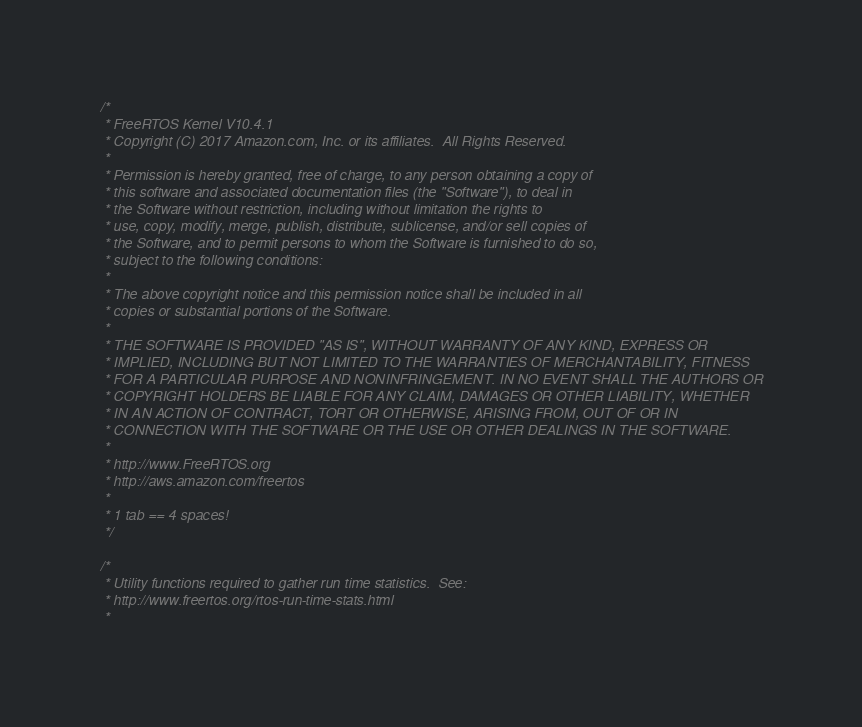<code> <loc_0><loc_0><loc_500><loc_500><_C_>/*
 * FreeRTOS Kernel V10.4.1
 * Copyright (C) 2017 Amazon.com, Inc. or its affiliates.  All Rights Reserved.
 *
 * Permission is hereby granted, free of charge, to any person obtaining a copy of
 * this software and associated documentation files (the "Software"), to deal in
 * the Software without restriction, including without limitation the rights to
 * use, copy, modify, merge, publish, distribute, sublicense, and/or sell copies of
 * the Software, and to permit persons to whom the Software is furnished to do so,
 * subject to the following conditions:
 *
 * The above copyright notice and this permission notice shall be included in all
 * copies or substantial portions of the Software.
 *
 * THE SOFTWARE IS PROVIDED "AS IS", WITHOUT WARRANTY OF ANY KIND, EXPRESS OR
 * IMPLIED, INCLUDING BUT NOT LIMITED TO THE WARRANTIES OF MERCHANTABILITY, FITNESS
 * FOR A PARTICULAR PURPOSE AND NONINFRINGEMENT. IN NO EVENT SHALL THE AUTHORS OR
 * COPYRIGHT HOLDERS BE LIABLE FOR ANY CLAIM, DAMAGES OR OTHER LIABILITY, WHETHER
 * IN AN ACTION OF CONTRACT, TORT OR OTHERWISE, ARISING FROM, OUT OF OR IN
 * CONNECTION WITH THE SOFTWARE OR THE USE OR OTHER DEALINGS IN THE SOFTWARE.
 *
 * http://www.FreeRTOS.org
 * http://aws.amazon.com/freertos
 *
 * 1 tab == 4 spaces!
 */

/*
 * Utility functions required to gather run time statistics.  See:
 * http://www.freertos.org/rtos-run-time-stats.html
 *</code> 